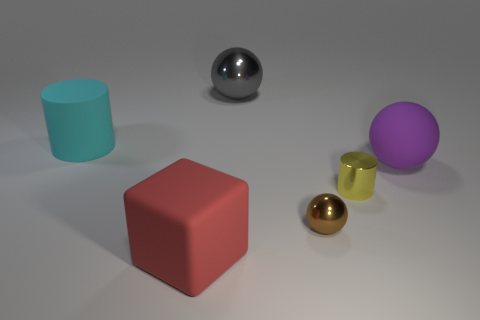What material is the cylinder that is in front of the big rubber object left of the red cube?
Provide a succinct answer. Metal. Is the number of small yellow cylinders in front of the tiny yellow metallic object greater than the number of big matte objects?
Provide a succinct answer. No. Are there any gray spheres made of the same material as the tiny yellow cylinder?
Keep it short and to the point. Yes. Is the shape of the rubber object that is behind the big purple object the same as  the big gray metal object?
Your response must be concise. No. There is a matte object that is right of the metal sphere behind the yellow cylinder; what number of big things are on the left side of it?
Ensure brevity in your answer.  3. Is the number of big red things behind the large purple matte ball less than the number of cyan rubber cylinders to the right of the tiny brown metallic sphere?
Your answer should be compact. No. There is a small metallic thing that is the same shape as the large gray metal thing; what is its color?
Your response must be concise. Brown. What is the size of the cube?
Provide a succinct answer. Large. What number of cubes have the same size as the cyan object?
Provide a succinct answer. 1. Is the large shiny thing the same color as the tiny metal ball?
Offer a very short reply. No. 